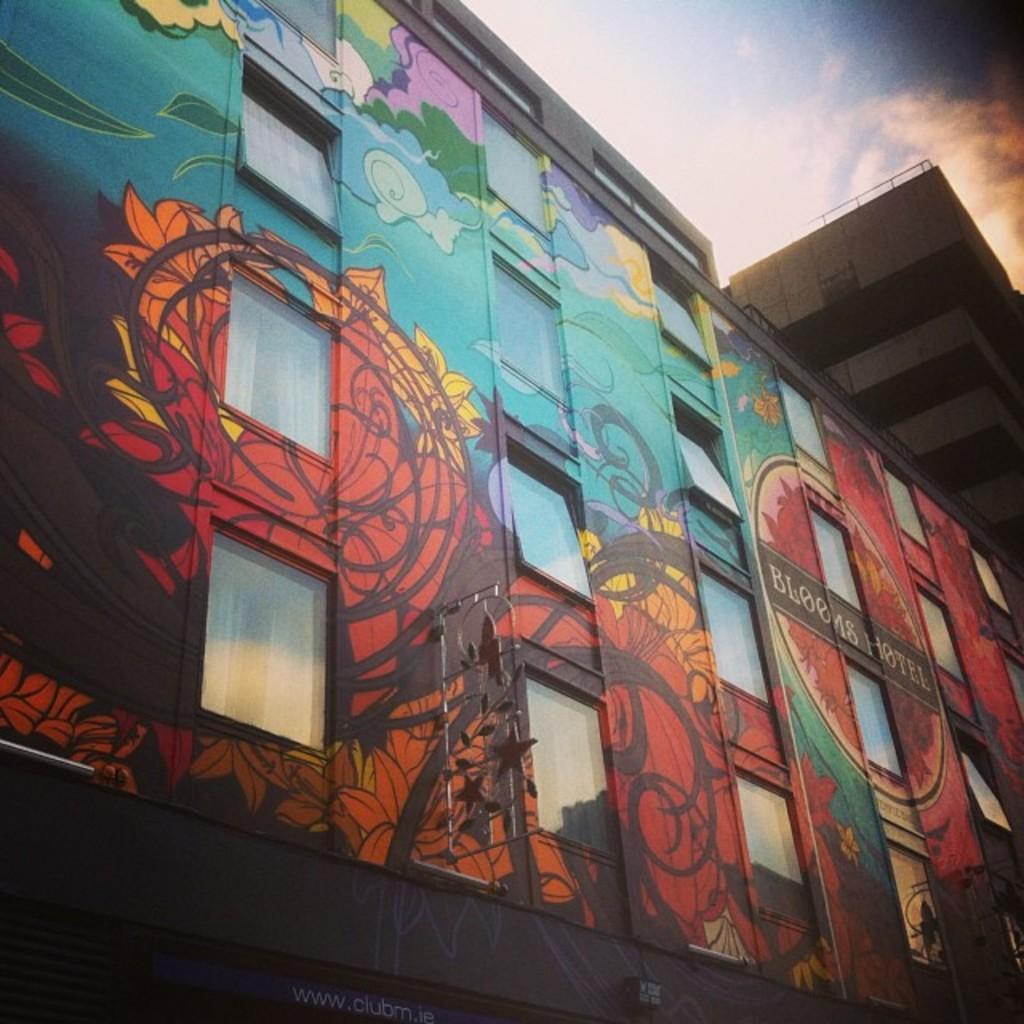In one or two sentences, can you explain what this image depicts? This is a building with the windows. I can see the colorful wall painting, which is painted on the building wall. I can see the letters written on the wall. These are the clouds in the sky. 